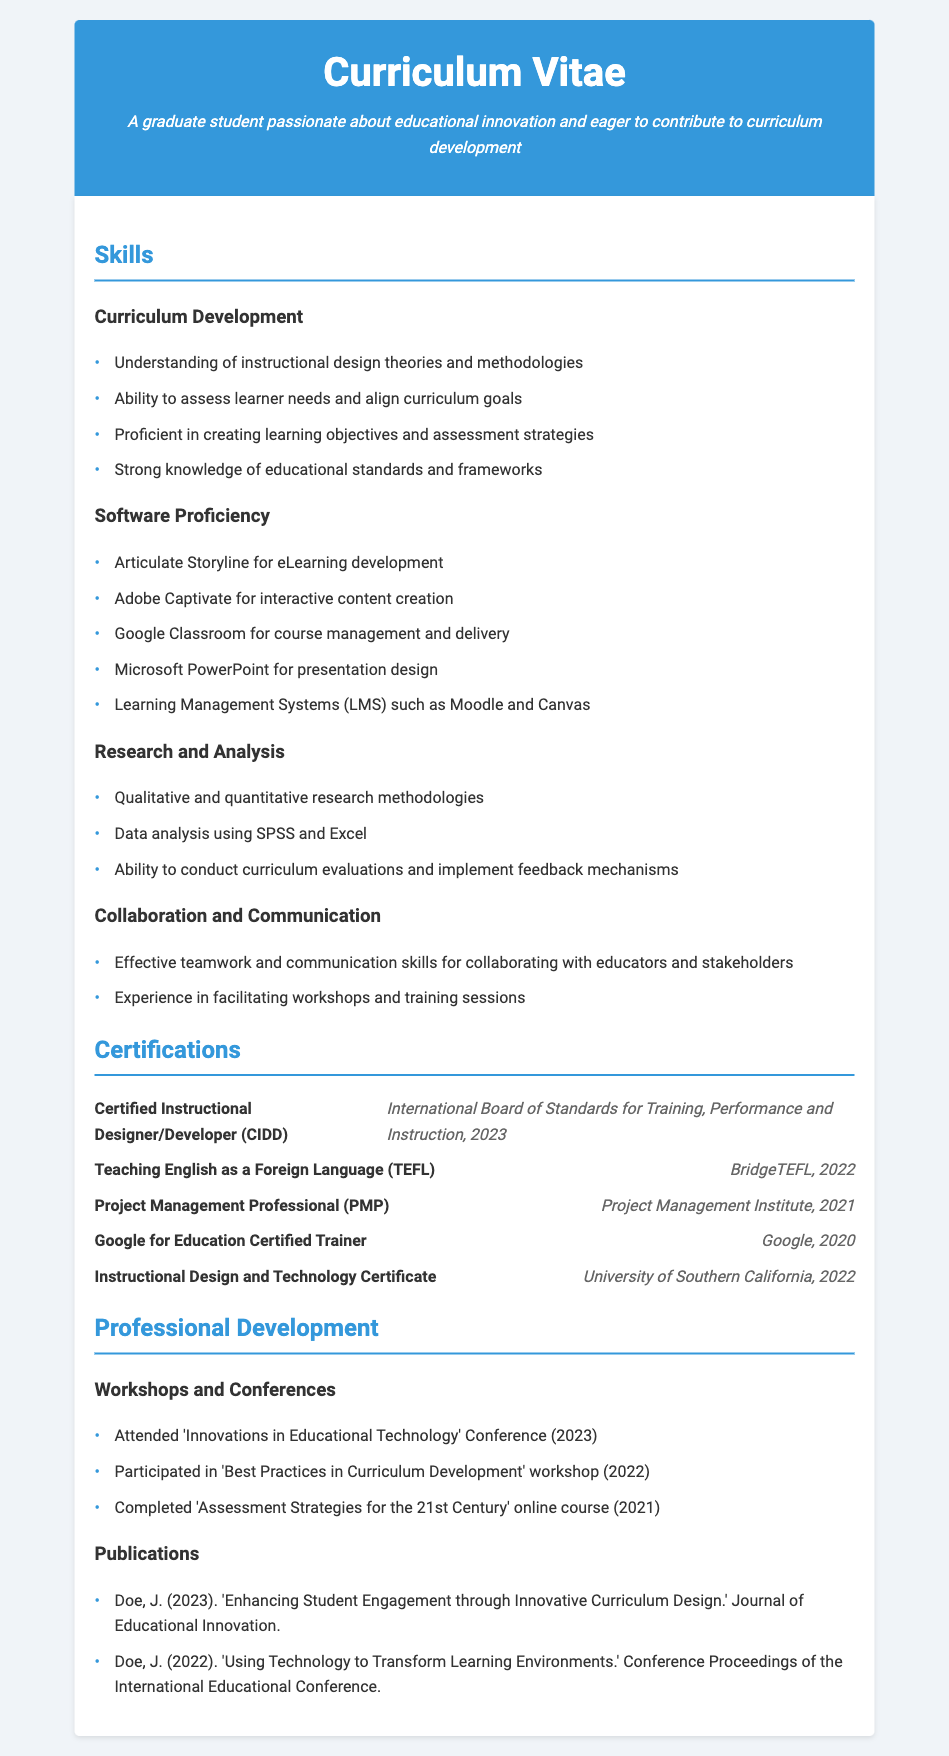what is the title of the certification obtained in 2023? The title of the certification obtained in 2023 is listed in the certifications section of the document.
Answer: Certified Instructional Designer/Developer (CIDD) how many years of experience does the individual have in project management? The individual is certified as a Project Management Professional in 2021, indicating a professional level of experience.
Answer: N/A which software is used for eLearning development? The software used specifically for eLearning development is mentioned in the software proficiency section.
Answer: Articulate Storyline what methodology is mentioned for research and analysis? The research and analysis section lists methodologies, and it specifically mentions the types of methodologies used.
Answer: Qualitative and quantitative research methodologies which certification was received from Google? The certification received from Google is specified within the certifications section under the name.
Answer: Google for Education Certified Trainer how many certifications are listed in the document? The number of certifications can be counted from the certifications section of the CV.
Answer: Five what is one of the skills related to communication mentioned? The skills section lists several communication-related skills, and one can be directly referenced.
Answer: Effective teamwork and communication skills for collaborating with educators and stakeholders which university awarded a certificate in instructional design and technology? The specific university that awarded the certificate is noted in the certifications section.
Answer: University of Southern California what year was the 'Innovations in Educational Technology' Conference attended? The year of attendance for the conference is specified in the professional development section.
Answer: 2023 